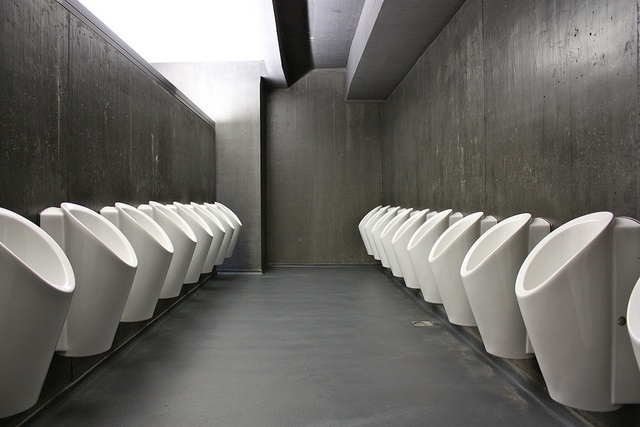Describe the objects in this image and their specific colors. I can see toilet in gray, darkgray, and lightgray tones, toilet in gray, lightgray, and black tones, toilet in gray, darkgray, black, and lightgray tones, toilet in gray, lightgray, and darkgray tones, and toilet in gray, darkgray, and lightgray tones in this image. 